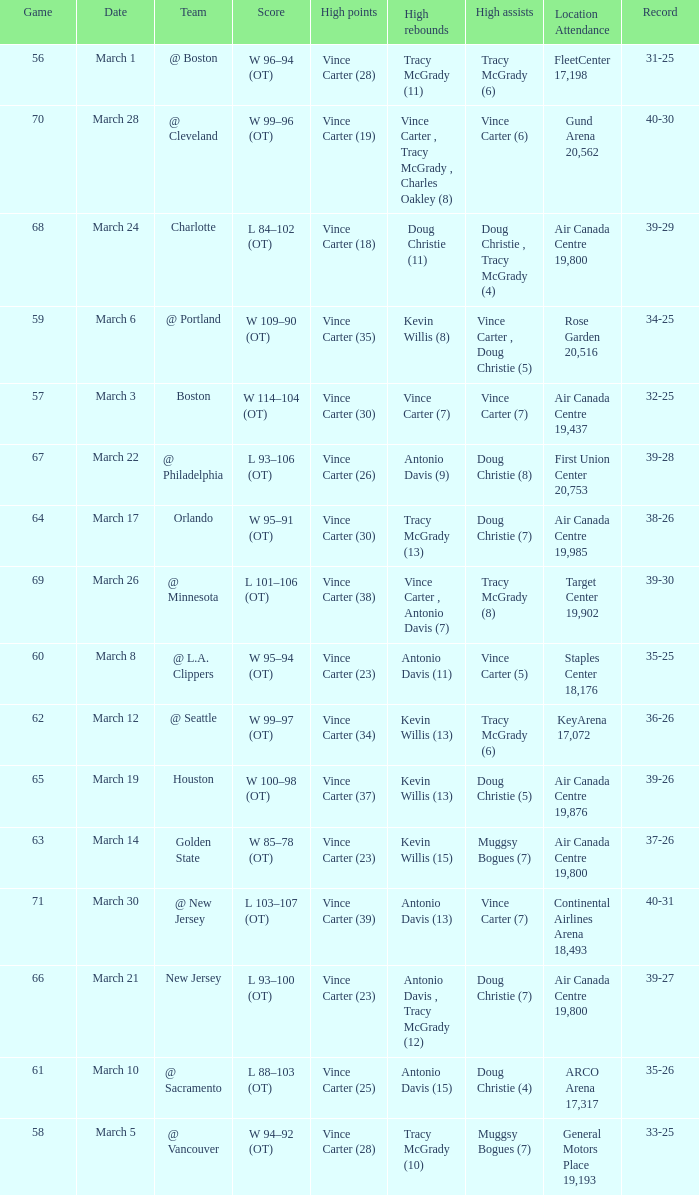Would you be able to parse every entry in this table? {'header': ['Game', 'Date', 'Team', 'Score', 'High points', 'High rebounds', 'High assists', 'Location Attendance', 'Record'], 'rows': [['56', 'March 1', '@ Boston', 'W 96–94 (OT)', 'Vince Carter (28)', 'Tracy McGrady (11)', 'Tracy McGrady (6)', 'FleetCenter 17,198', '31-25'], ['70', 'March 28', '@ Cleveland', 'W 99–96 (OT)', 'Vince Carter (19)', 'Vince Carter , Tracy McGrady , Charles Oakley (8)', 'Vince Carter (6)', 'Gund Arena 20,562', '40-30'], ['68', 'March 24', 'Charlotte', 'L 84–102 (OT)', 'Vince Carter (18)', 'Doug Christie (11)', 'Doug Christie , Tracy McGrady (4)', 'Air Canada Centre 19,800', '39-29'], ['59', 'March 6', '@ Portland', 'W 109–90 (OT)', 'Vince Carter (35)', 'Kevin Willis (8)', 'Vince Carter , Doug Christie (5)', 'Rose Garden 20,516', '34-25'], ['57', 'March 3', 'Boston', 'W 114–104 (OT)', 'Vince Carter (30)', 'Vince Carter (7)', 'Vince Carter (7)', 'Air Canada Centre 19,437', '32-25'], ['67', 'March 22', '@ Philadelphia', 'L 93–106 (OT)', 'Vince Carter (26)', 'Antonio Davis (9)', 'Doug Christie (8)', 'First Union Center 20,753', '39-28'], ['64', 'March 17', 'Orlando', 'W 95–91 (OT)', 'Vince Carter (30)', 'Tracy McGrady (13)', 'Doug Christie (7)', 'Air Canada Centre 19,985', '38-26'], ['69', 'March 26', '@ Minnesota', 'L 101–106 (OT)', 'Vince Carter (38)', 'Vince Carter , Antonio Davis (7)', 'Tracy McGrady (8)', 'Target Center 19,902', '39-30'], ['60', 'March 8', '@ L.A. Clippers', 'W 95–94 (OT)', 'Vince Carter (23)', 'Antonio Davis (11)', 'Vince Carter (5)', 'Staples Center 18,176', '35-25'], ['62', 'March 12', '@ Seattle', 'W 99–97 (OT)', 'Vince Carter (34)', 'Kevin Willis (13)', 'Tracy McGrady (6)', 'KeyArena 17,072', '36-26'], ['65', 'March 19', 'Houston', 'W 100–98 (OT)', 'Vince Carter (37)', 'Kevin Willis (13)', 'Doug Christie (5)', 'Air Canada Centre 19,876', '39-26'], ['63', 'March 14', 'Golden State', 'W 85–78 (OT)', 'Vince Carter (23)', 'Kevin Willis (15)', 'Muggsy Bogues (7)', 'Air Canada Centre 19,800', '37-26'], ['71', 'March 30', '@ New Jersey', 'L 103–107 (OT)', 'Vince Carter (39)', 'Antonio Davis (13)', 'Vince Carter (7)', 'Continental Airlines Arena 18,493', '40-31'], ['66', 'March 21', 'New Jersey', 'L 93–100 (OT)', 'Vince Carter (23)', 'Antonio Davis , Tracy McGrady (12)', 'Doug Christie (7)', 'Air Canada Centre 19,800', '39-27'], ['61', 'March 10', '@ Sacramento', 'L 88–103 (OT)', 'Vince Carter (25)', 'Antonio Davis (15)', 'Doug Christie (4)', 'ARCO Arena 17,317', '35-26'], ['58', 'March 5', '@ Vancouver', 'W 94–92 (OT)', 'Vince Carter (28)', 'Tracy McGrady (10)', 'Muggsy Bogues (7)', 'General Motors Place 19,193', '33-25']]} What day was the attendance at the staples center 18,176? March 8. 